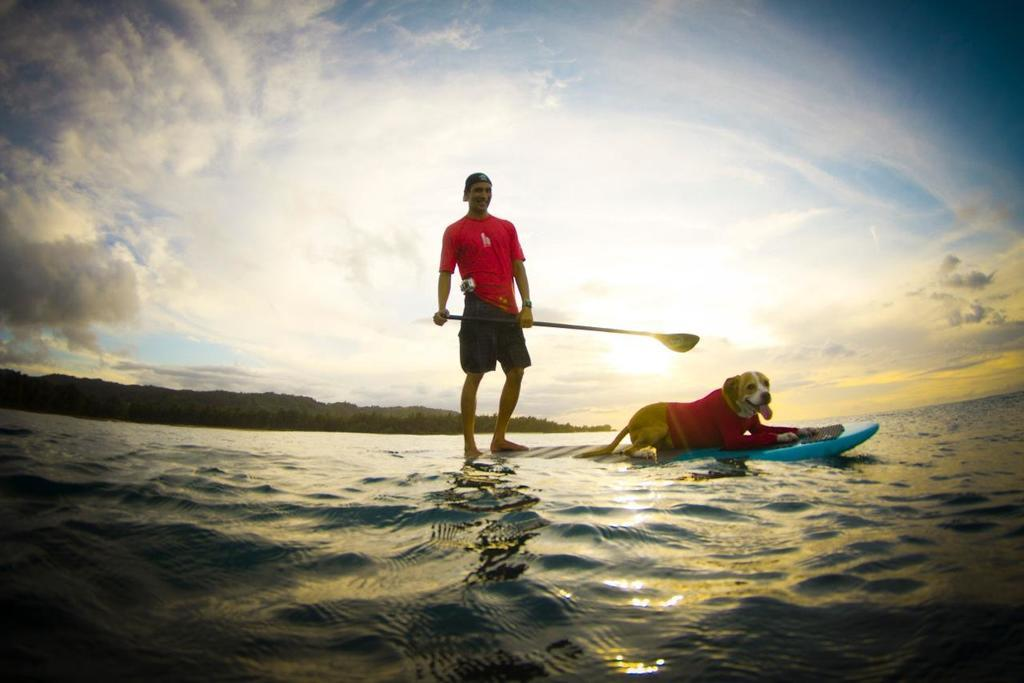What animal can be seen in the image? There is a dog in the image. What is the dog doing in the image? The dog is laying on a surfing board. Who is behind the dog in the image? There is a man behind the dog. What is the surfing board floating on in the image? The surfing board is floating on the water surface. What can be seen in the distance in the image? There is a mountain visible in the background. What type of button is the dog wearing on its vest in the image? There is no button or vest present on the dog in the image. How many cats can be seen playing with the dog on the surfing board in the image? There are no cats present in the image; only the dog and the man can be seen. 